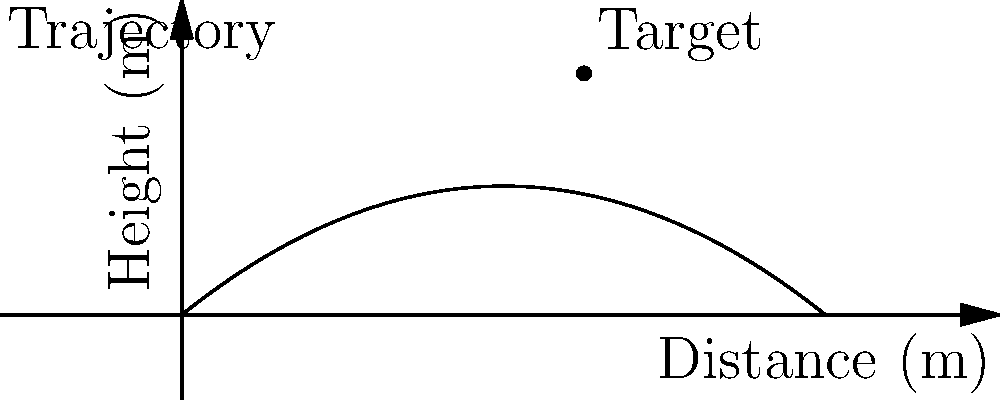As a former field agent, you're writing a scene involving a sniper shot. The bullet's trajectory is modeled by the function $h(x) = -0.05x^2 + 0.8x$, where $h$ is the height in meters and $x$ is the horizontal distance in meters. The target is located 10 meters away at a height of 6 meters. At what angle (in degrees) should the sniper aim to hit the target precisely? To find the angle at which the sniper should aim, we need to follow these steps:

1) First, we need to find the derivative of the trajectory function:
   $h'(x) = -0.1x + 0.8$

2) The derivative at the point where the bullet hits the target gives us the slope of the trajectory at that point. We can use this to calculate the angle.

3) Find the slope at x = 10 meters:
   $h'(10) = -0.1(10) + 0.8 = -0.2$

4) The slope is the tangent of the angle we're looking for. So:
   $\tan(\theta) = -0.2$

5) To get the angle, we need to use the arctangent (inverse tangent) function:
   $\theta = \arctan(-0.2)$

6) Convert from radians to degrees:
   $\theta = \arctan(-0.2) * \frac{180}{\pi}$

7) Calculate:
   $\theta \approx -11.31°$

8) The negative angle means the sniper needs to aim 11.31° below the horizontal.
Answer: $11.31°$ below horizontal 